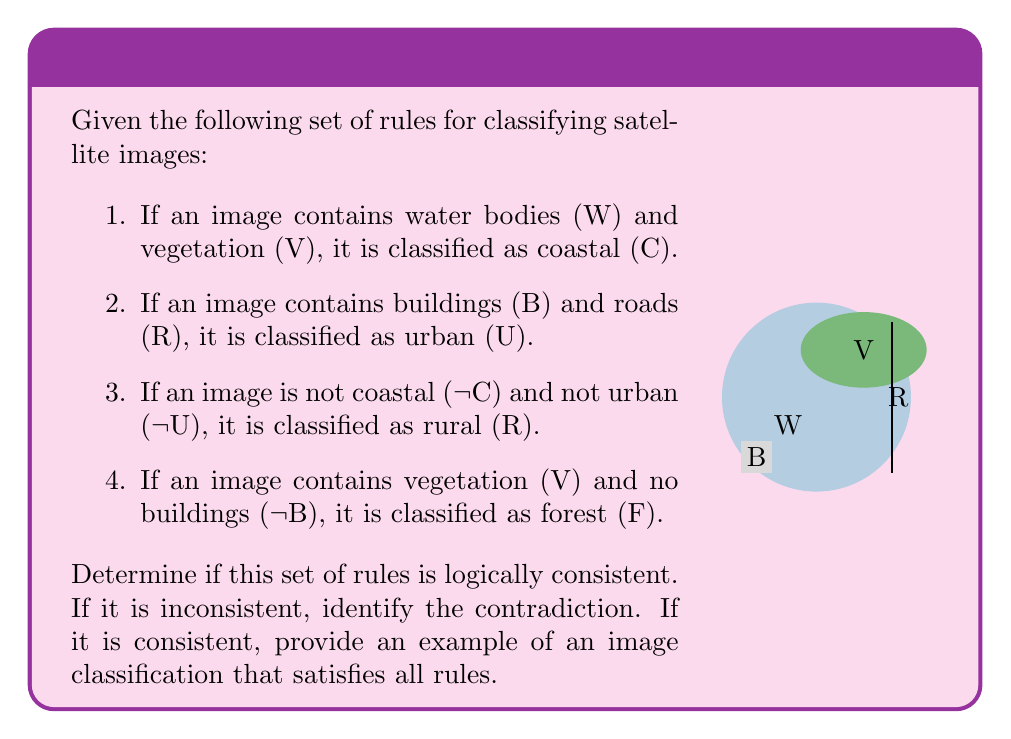Show me your answer to this math problem. To determine if the set of rules is logically consistent, we need to check if there are any contradictions or if all rules can be satisfied simultaneously. Let's analyze each rule:

1. $C \iff W \land V$
2. $U \iff B \land R$
3. $R \iff \lnot C \land \lnot U$
4. $F \iff V \land \lnot B$

Step 1: Check for direct contradictions
There are no direct contradictions between the rules. Each rule defines a distinct classification based on different combinations of features.

Step 2: Check for indirect contradictions
Let's consider possible combinations of features:

a) $W \land V \land \lnot B \land \lnot R$: This satisfies rules 1 and 4, classifying the image as both coastal (C) and forest (F). It doesn't violate rules 2 or 3.

b) $B \land R \land \lnot W \land \lnot V$: This satisfies rule 2, classifying the image as urban (U). It doesn't violate any other rules.

c) $\lnot W \land V \land \lnot B \land \lnot R$: This satisfies rules 3 and 4, classifying the image as both rural (R) and forest (F). It doesn't violate rules 1 or 2.

d) $\lnot W \land \lnot V \land \lnot B \land \lnot R$: This satisfies rule 3, classifying the image as rural (R). It doesn't violate any other rules.

Step 3: Conclusion
We can see that there are no contradictions between the rules. It's possible to have images that satisfy multiple classifications (e.g., coastal and forest, or rural and forest) without violating any rules. Therefore, the set of rules is logically consistent.

To provide an example that satisfies all rules, we can use case (a) from our analysis:

An image containing water bodies (W) and vegetation (V), but no buildings (¬B) or roads (¬R), would be classified as both coastal (C) and forest (F). This satisfies rules 1 and 4 directly, and doesn't violate rules 2 or 3.
Answer: Consistent; Example: $W \land V \land \lnot B \land \lnot R \implies C \land F$ 